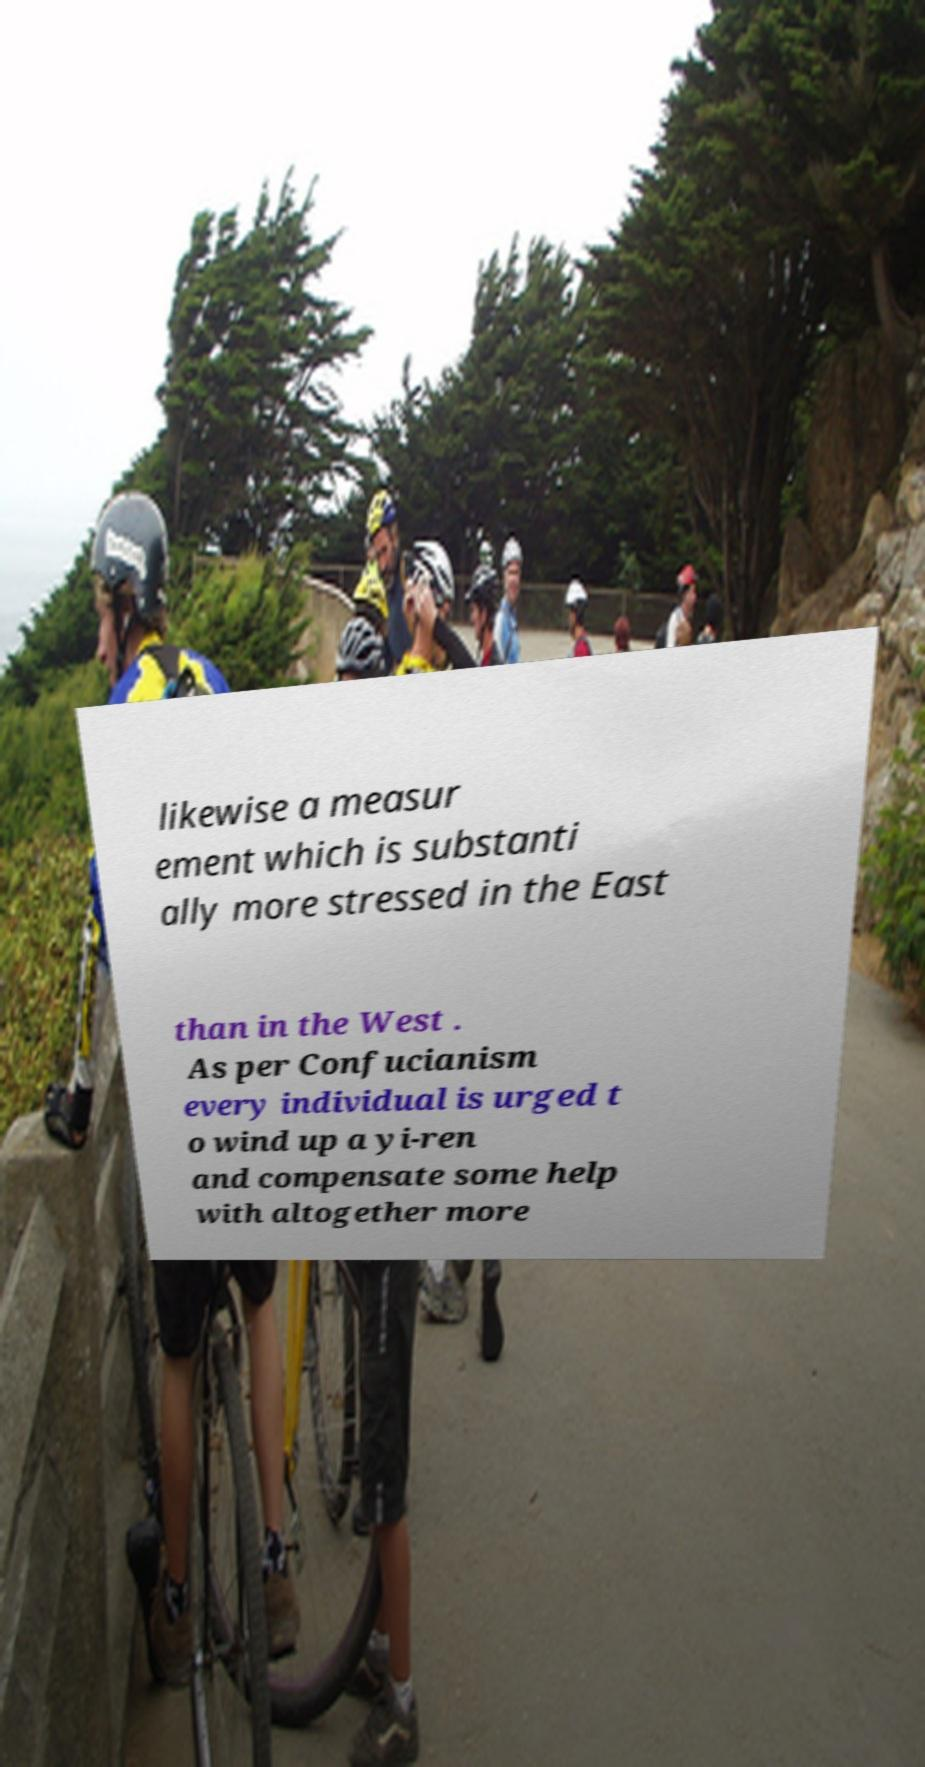There's text embedded in this image that I need extracted. Can you transcribe it verbatim? likewise a measur ement which is substanti ally more stressed in the East than in the West . As per Confucianism every individual is urged t o wind up a yi-ren and compensate some help with altogether more 